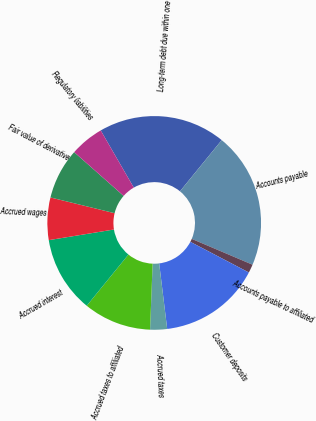<chart> <loc_0><loc_0><loc_500><loc_500><pie_chart><fcel>Long-term debt due within one<fcel>Accounts payable<fcel>Accounts payable to affiliated<fcel>Customer deposits<fcel>Accrued taxes<fcel>Accrued taxes to affiliated<fcel>Accrued interest<fcel>Accrued wages<fcel>Fair value of derivative<fcel>Regulatory liabilities<nl><fcel>19.23%<fcel>20.51%<fcel>1.28%<fcel>15.38%<fcel>2.56%<fcel>10.26%<fcel>11.54%<fcel>6.41%<fcel>7.69%<fcel>5.13%<nl></chart> 